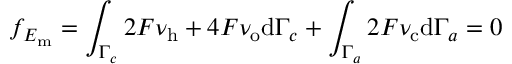Convert formula to latex. <formula><loc_0><loc_0><loc_500><loc_500>f _ { E _ { m } } = \int _ { \Gamma _ { c } } 2 F \nu _ { h } + 4 F \nu _ { o } d \Gamma _ { c } + \int _ { \Gamma _ { a } } 2 F \nu _ { c } d \Gamma _ { a } = 0</formula> 